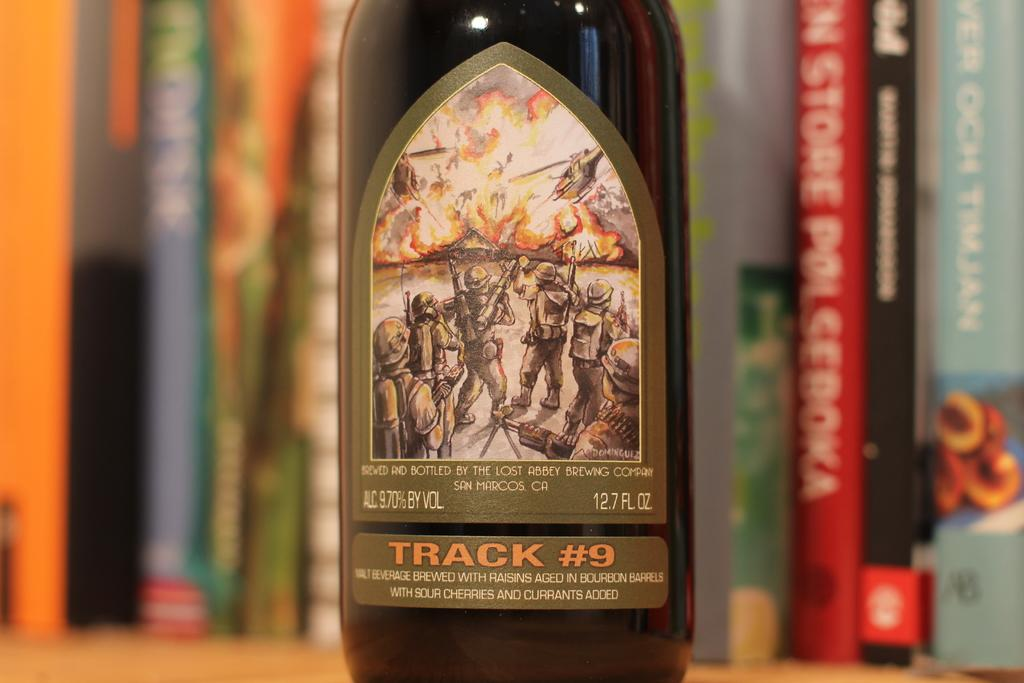Provide a one-sentence caption for the provided image. A book shelf with books on it also has a bottle of Track #9 beer on it. 